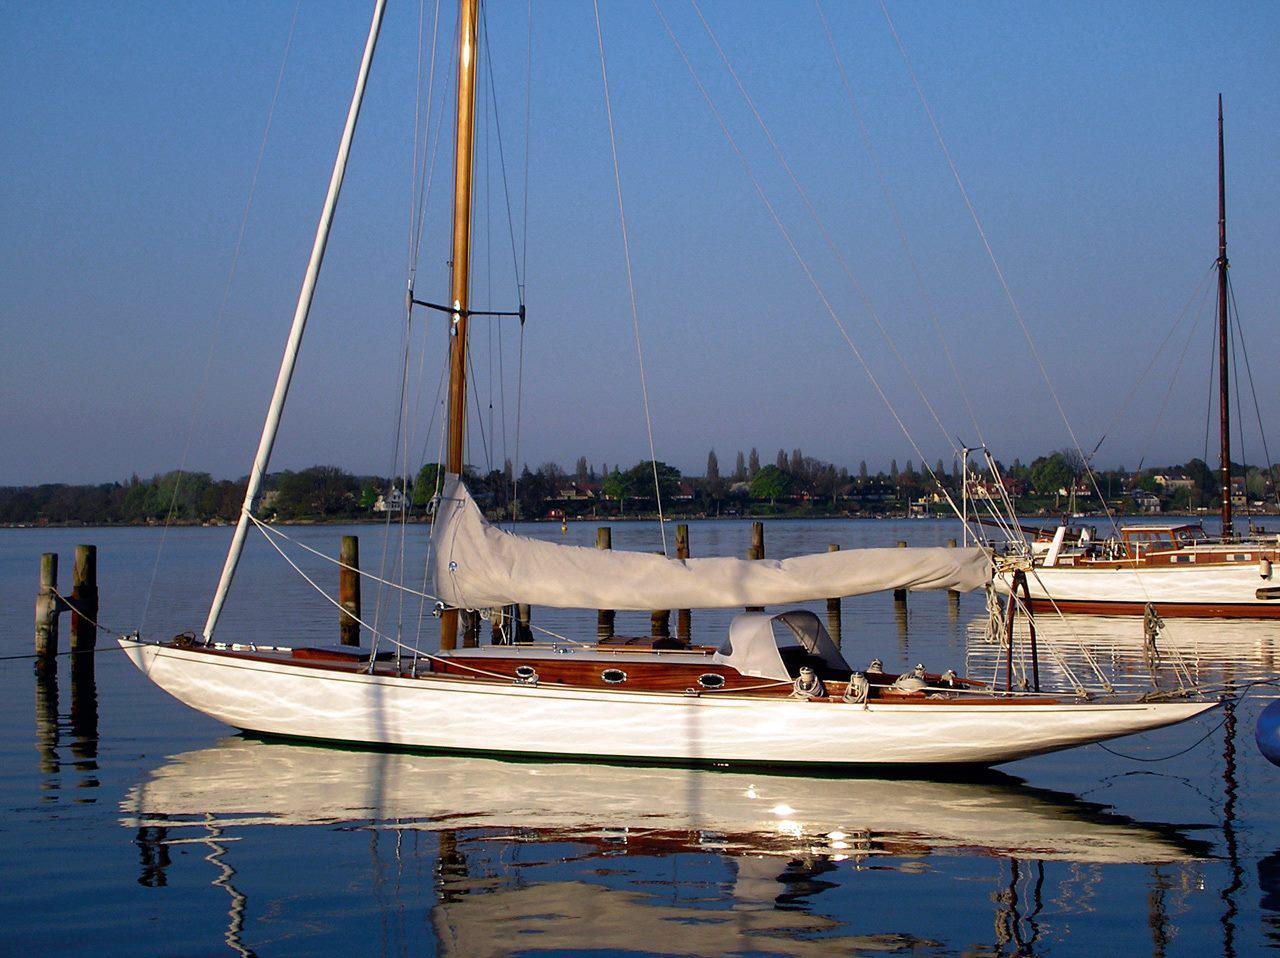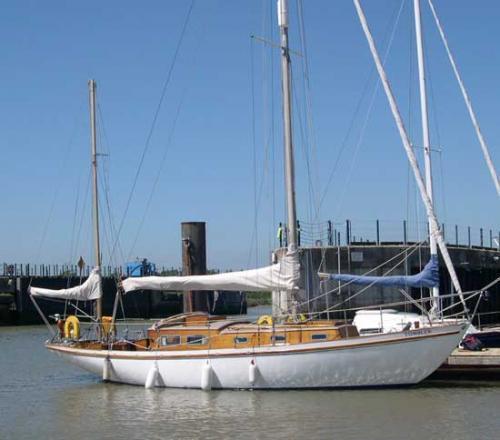The first image is the image on the left, the second image is the image on the right. For the images shown, is this caption "At least one boat has a black body." true? Answer yes or no. No. The first image is the image on the left, the second image is the image on the right. Evaluate the accuracy of this statement regarding the images: "The boat on the right has a blue sail cover covering one of the sails.". Is it true? Answer yes or no. Yes. 